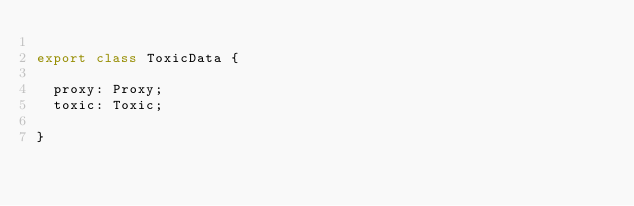Convert code to text. <code><loc_0><loc_0><loc_500><loc_500><_TypeScript_>
export class ToxicData {

  proxy: Proxy;
  toxic: Toxic;

}
</code> 